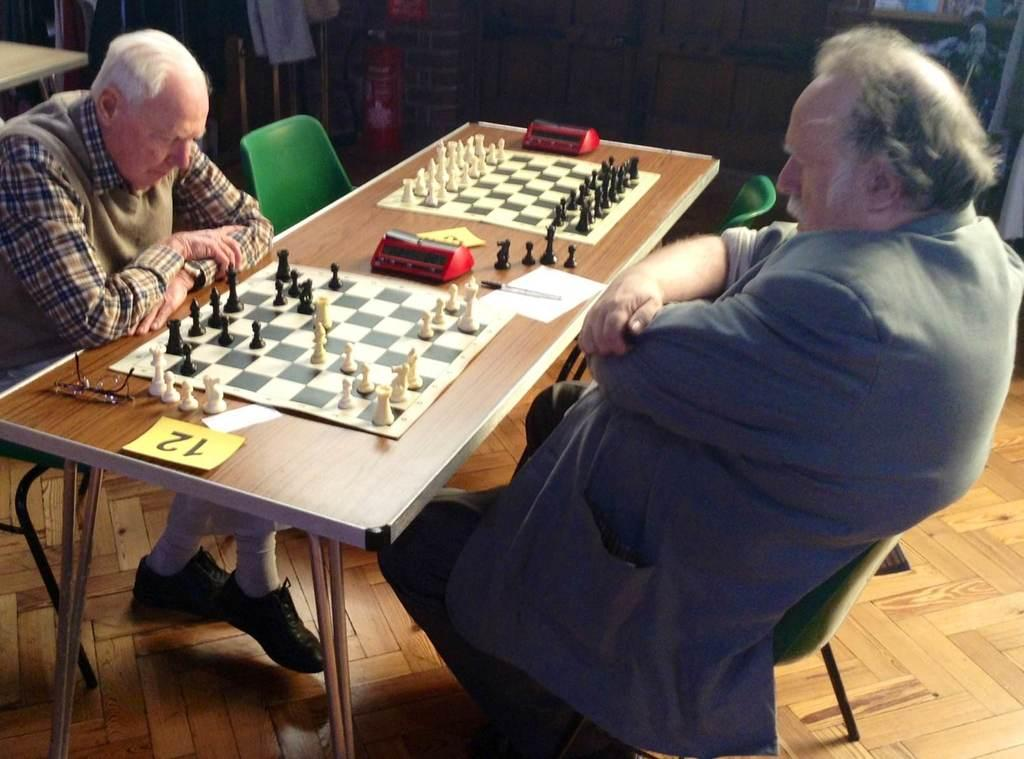How many people are sitting in the image? There are two men sitting on chairs in the image. What game are they playing? They are playing chess, as evidenced by the chess board and chess pieces in the image. What objects can be seen on the table? There are glasses and other objects on the table in the image. What type of wall is visible in the background? There is a wooden wall in the background of the image. What other furniture can be seen in the background? There is a table in the background of the image. What surface is visible beneath the table and chairs? There is a floor visible in the image. What type of underwear is the man on the left wearing in the image? There is no information about the men's underwear in the image, as it is not visible or mentioned in the provided facts. What type of competition is taking place in the image? There is no competition taking place in the image; it is simply a scene of two men playing chess. 